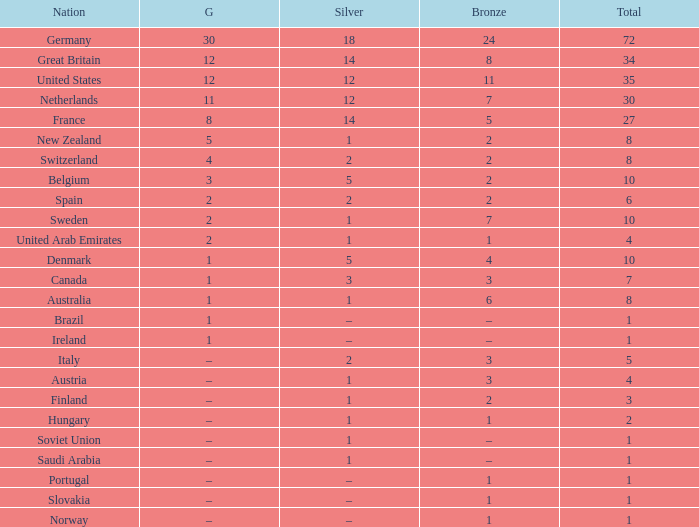What is Bronze, when Silver is 2, and when Nation is Italy? 3.0. 